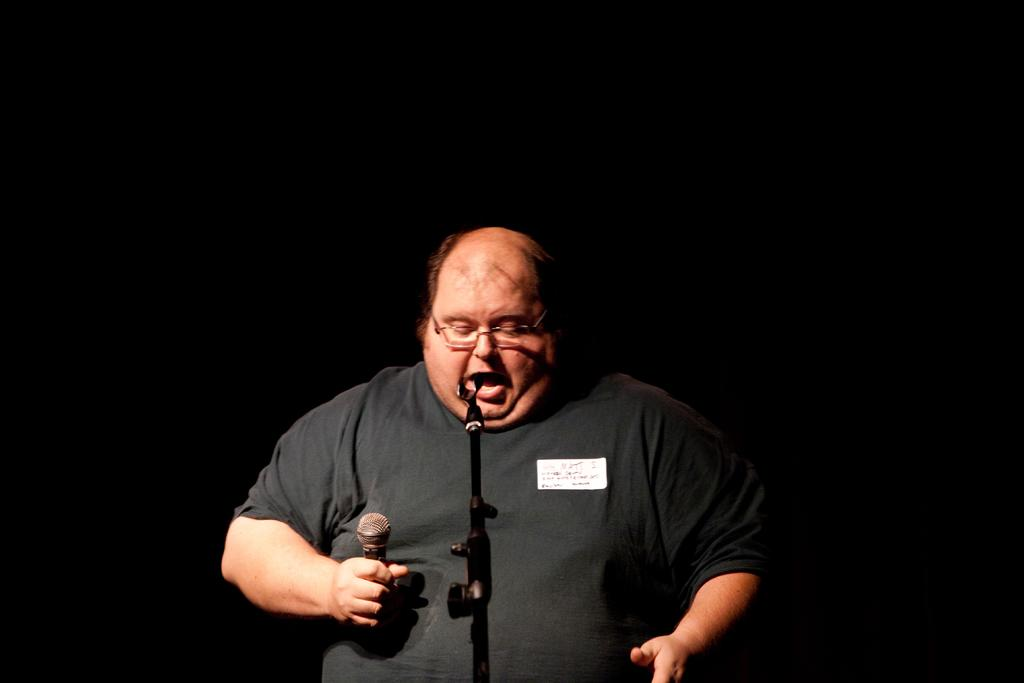Who is present in the image? There is a man in the image. What is the man wearing? The man is wearing a black t-shirt. What is the man holding in the image? The man is holding a mic. What can be seen in the image that might be used for stabilizing a camera? There is a tripod in the image. What is the color of the background in the image? The background of the image is dark. What type of beast can be seen lurking in the shadows of the dark background? There is no beast present in the image; the background is dark, but no creatures are visible. How many snakes are coiled around the tripod in the image? There are no snakes present in the image; the tripod is used for stabilizing a camera, and no snakes are visible. 